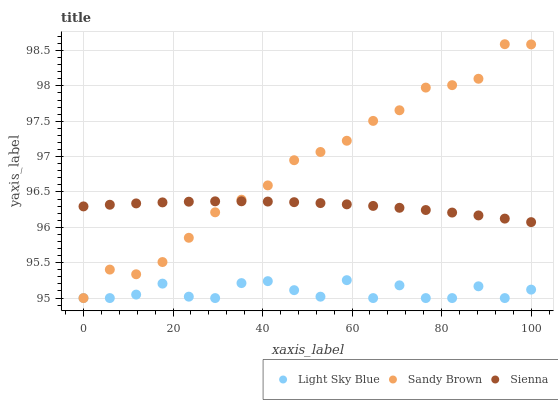Does Light Sky Blue have the minimum area under the curve?
Answer yes or no. Yes. Does Sandy Brown have the maximum area under the curve?
Answer yes or no. Yes. Does Sandy Brown have the minimum area under the curve?
Answer yes or no. No. Does Light Sky Blue have the maximum area under the curve?
Answer yes or no. No. Is Sienna the smoothest?
Answer yes or no. Yes. Is Light Sky Blue the roughest?
Answer yes or no. Yes. Is Sandy Brown the smoothest?
Answer yes or no. No. Is Sandy Brown the roughest?
Answer yes or no. No. Does Light Sky Blue have the lowest value?
Answer yes or no. Yes. Does Sandy Brown have the highest value?
Answer yes or no. Yes. Does Light Sky Blue have the highest value?
Answer yes or no. No. Is Light Sky Blue less than Sienna?
Answer yes or no. Yes. Is Sienna greater than Light Sky Blue?
Answer yes or no. Yes. Does Sienna intersect Sandy Brown?
Answer yes or no. Yes. Is Sienna less than Sandy Brown?
Answer yes or no. No. Is Sienna greater than Sandy Brown?
Answer yes or no. No. Does Light Sky Blue intersect Sienna?
Answer yes or no. No. 